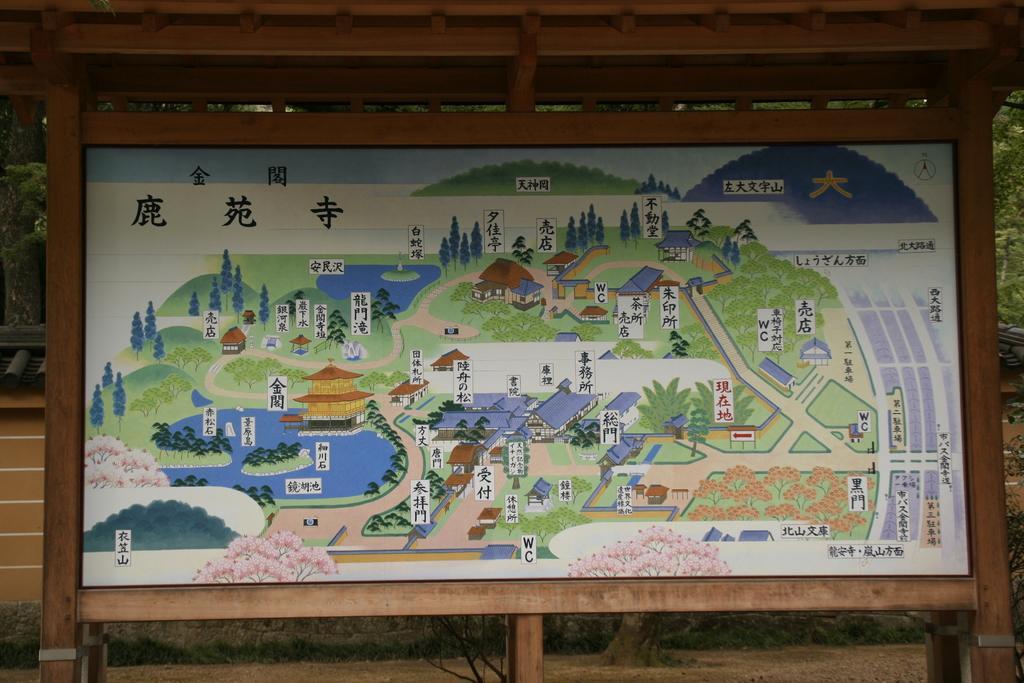Please provide a concise description of this image. In this image, we can see the photo of a map. 